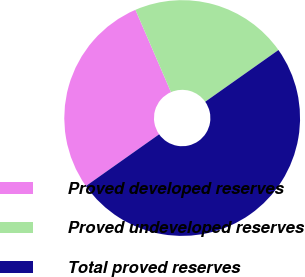<chart> <loc_0><loc_0><loc_500><loc_500><pie_chart><fcel>Proved developed reserves<fcel>Proved undeveloped reserves<fcel>Total proved reserves<nl><fcel>28.3%<fcel>21.7%<fcel>50.0%<nl></chart> 